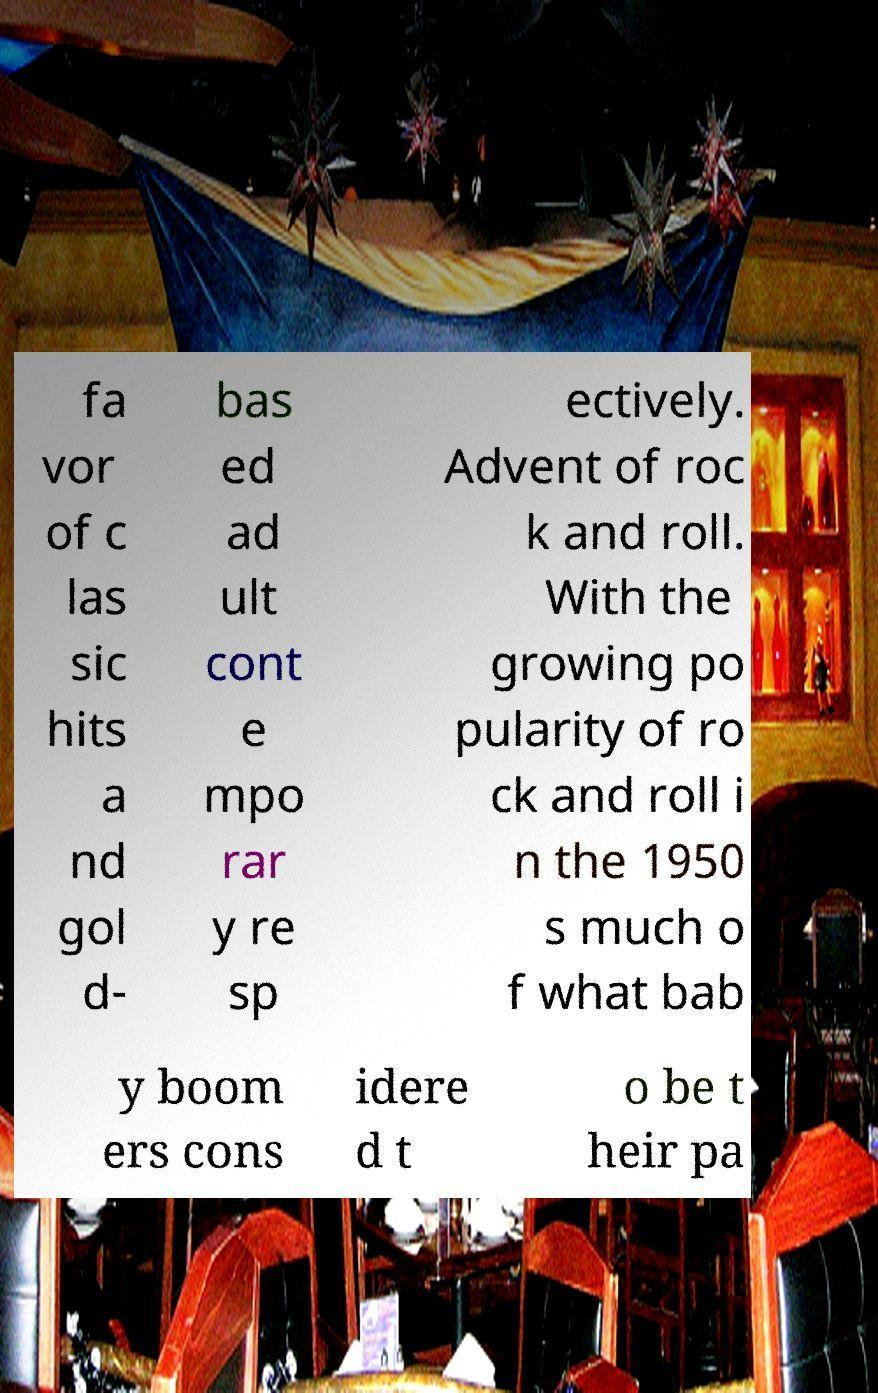I need the written content from this picture converted into text. Can you do that? fa vor of c las sic hits a nd gol d- bas ed ad ult cont e mpo rar y re sp ectively. Advent of roc k and roll. With the growing po pularity of ro ck and roll i n the 1950 s much o f what bab y boom ers cons idere d t o be t heir pa 